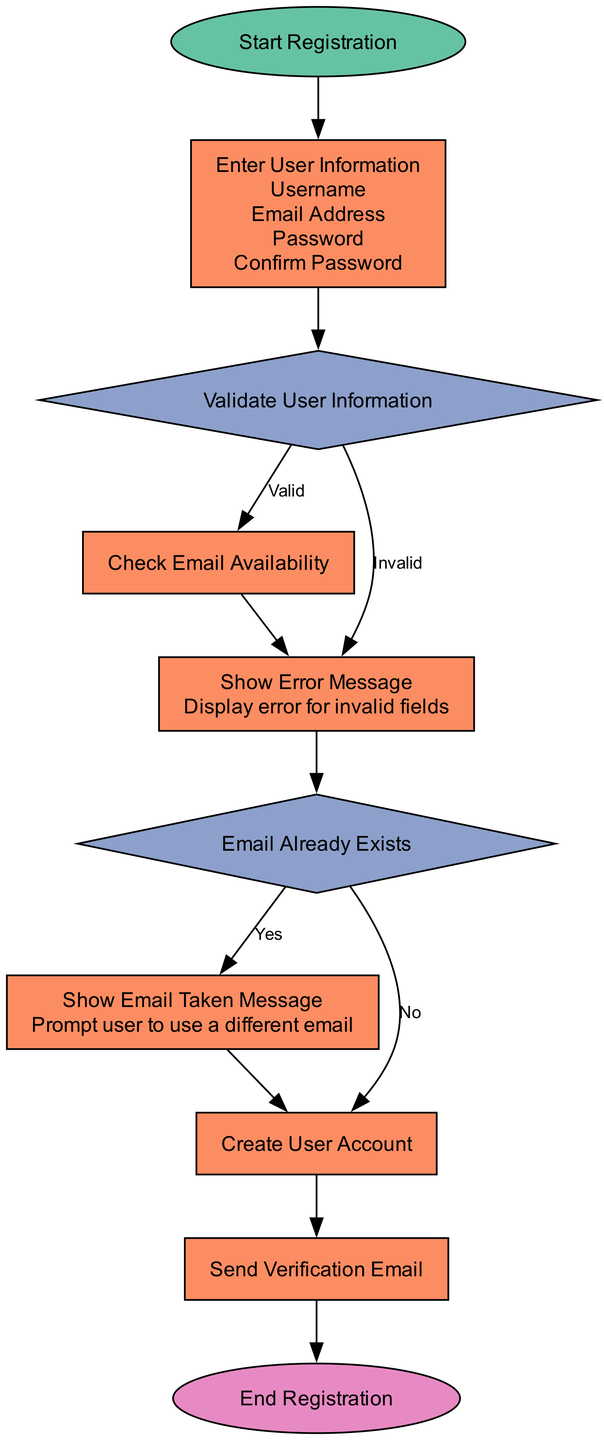What is the first step in the registration process? The diagram starts with the "Start Registration" node, indicating the first action in the flow.
Answer: Start Registration How many processes are in the registration flow? Counting the nodes labeled as "Process," there are five of them: "Enter User Information," "Check Email Availability," "Show Error Message," "Create User Account," and "Send Verification Email."
Answer: Five What message is displayed if the user information is invalid? The flow leads to the "Show Error Message" process, which specifies that an error is displayed for invalid fields.
Answer: Display error for invalid fields If the email is already taken, what is the next step? The flow indicates that if the email exists, the user goes to the "Show Email Taken Message" process to prompt using a different email.
Answer: Show Email Taken Message What is the final action in the registration process? The last node in the diagram is "End Registration," which represents the conclusion of the registration steps.
Answer: End Registration What happens after validating user information if it’s deemed valid? The flow chart shows that upon validation as valid, the next step is "Check Email Availability," proceeding to check if the provided email can be used.
Answer: Check Email Availability What is the outcome if the email does not exist? If the email availability check results in "No," the next action is to "Create User Account," allowing the registration to move forward.
Answer: Create User Account How many decision points are there in the diagram? There are two decision nodes in the flow: "Validate User Information" and "Email Already Exists," indicating points where different outcomes are possible based on conditions.
Answer: Two What type of node is used to represent the start of the process? The starting point of the flow chart is depicted as an oval shape, specifically labeled "Start Registration."
Answer: Start 